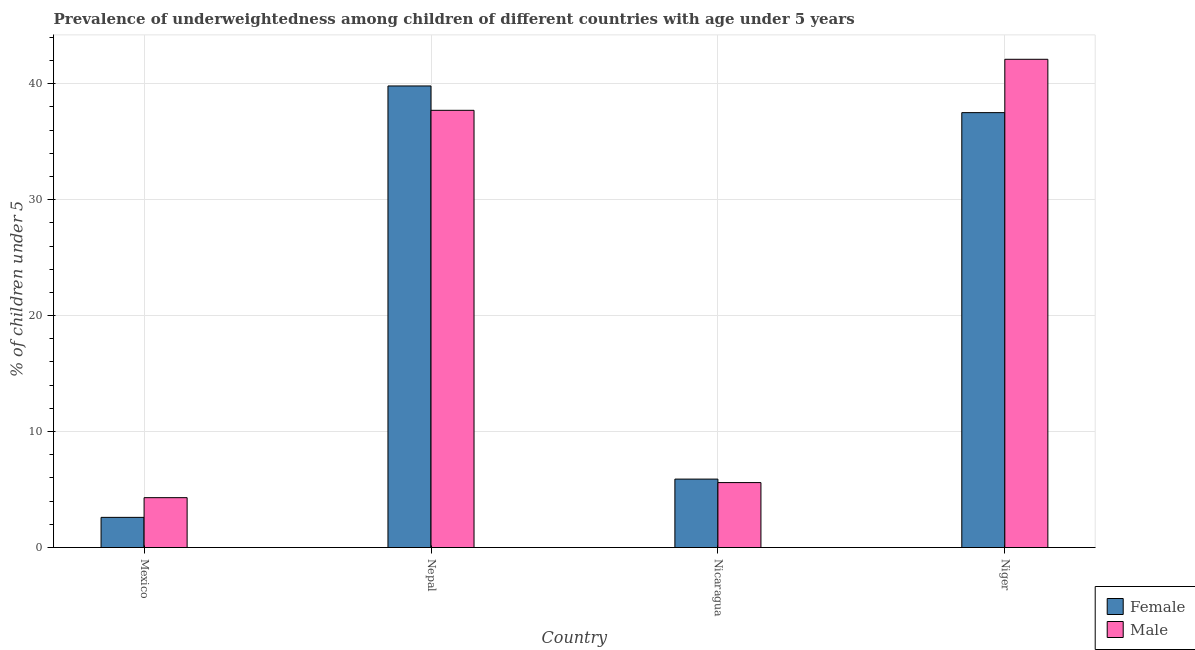How many groups of bars are there?
Offer a very short reply. 4. Are the number of bars per tick equal to the number of legend labels?
Make the answer very short. Yes. What is the label of the 1st group of bars from the left?
Offer a very short reply. Mexico. In how many cases, is the number of bars for a given country not equal to the number of legend labels?
Offer a terse response. 0. What is the percentage of underweighted male children in Nicaragua?
Provide a short and direct response. 5.6. Across all countries, what is the maximum percentage of underweighted female children?
Offer a terse response. 39.8. Across all countries, what is the minimum percentage of underweighted female children?
Provide a short and direct response. 2.6. In which country was the percentage of underweighted male children maximum?
Keep it short and to the point. Niger. What is the total percentage of underweighted male children in the graph?
Offer a terse response. 89.7. What is the difference between the percentage of underweighted male children in Mexico and that in Nepal?
Your answer should be compact. -33.4. What is the difference between the percentage of underweighted male children in Mexico and the percentage of underweighted female children in Nepal?
Make the answer very short. -35.5. What is the average percentage of underweighted female children per country?
Make the answer very short. 21.45. What is the difference between the percentage of underweighted male children and percentage of underweighted female children in Mexico?
Your answer should be compact. 1.7. In how many countries, is the percentage of underweighted male children greater than 14 %?
Offer a terse response. 2. What is the ratio of the percentage of underweighted female children in Nicaragua to that in Niger?
Provide a short and direct response. 0.16. Is the percentage of underweighted male children in Mexico less than that in Nepal?
Provide a short and direct response. Yes. What is the difference between the highest and the second highest percentage of underweighted female children?
Your response must be concise. 2.3. What is the difference between the highest and the lowest percentage of underweighted female children?
Provide a succinct answer. 37.2. Is the sum of the percentage of underweighted female children in Mexico and Nepal greater than the maximum percentage of underweighted male children across all countries?
Your response must be concise. Yes. What does the 1st bar from the left in Niger represents?
Your response must be concise. Female. What does the 2nd bar from the right in Mexico represents?
Offer a terse response. Female. What is the difference between two consecutive major ticks on the Y-axis?
Offer a terse response. 10. Are the values on the major ticks of Y-axis written in scientific E-notation?
Provide a short and direct response. No. How many legend labels are there?
Give a very brief answer. 2. How are the legend labels stacked?
Provide a succinct answer. Vertical. What is the title of the graph?
Ensure brevity in your answer.  Prevalence of underweightedness among children of different countries with age under 5 years. What is the label or title of the Y-axis?
Your answer should be compact.  % of children under 5. What is the  % of children under 5 in Female in Mexico?
Your answer should be very brief. 2.6. What is the  % of children under 5 in Male in Mexico?
Offer a very short reply. 4.3. What is the  % of children under 5 in Female in Nepal?
Your answer should be very brief. 39.8. What is the  % of children under 5 of Male in Nepal?
Provide a short and direct response. 37.7. What is the  % of children under 5 of Female in Nicaragua?
Keep it short and to the point. 5.9. What is the  % of children under 5 in Male in Nicaragua?
Offer a terse response. 5.6. What is the  % of children under 5 of Female in Niger?
Your answer should be compact. 37.5. What is the  % of children under 5 in Male in Niger?
Provide a succinct answer. 42.1. Across all countries, what is the maximum  % of children under 5 of Female?
Ensure brevity in your answer.  39.8. Across all countries, what is the maximum  % of children under 5 in Male?
Your answer should be very brief. 42.1. Across all countries, what is the minimum  % of children under 5 of Female?
Make the answer very short. 2.6. Across all countries, what is the minimum  % of children under 5 in Male?
Offer a very short reply. 4.3. What is the total  % of children under 5 of Female in the graph?
Your answer should be compact. 85.8. What is the total  % of children under 5 of Male in the graph?
Ensure brevity in your answer.  89.7. What is the difference between the  % of children under 5 of Female in Mexico and that in Nepal?
Ensure brevity in your answer.  -37.2. What is the difference between the  % of children under 5 in Male in Mexico and that in Nepal?
Provide a short and direct response. -33.4. What is the difference between the  % of children under 5 in Female in Mexico and that in Nicaragua?
Provide a succinct answer. -3.3. What is the difference between the  % of children under 5 in Male in Mexico and that in Nicaragua?
Ensure brevity in your answer.  -1.3. What is the difference between the  % of children under 5 of Female in Mexico and that in Niger?
Provide a succinct answer. -34.9. What is the difference between the  % of children under 5 of Male in Mexico and that in Niger?
Your response must be concise. -37.8. What is the difference between the  % of children under 5 of Female in Nepal and that in Nicaragua?
Your answer should be compact. 33.9. What is the difference between the  % of children under 5 in Male in Nepal and that in Nicaragua?
Make the answer very short. 32.1. What is the difference between the  % of children under 5 of Male in Nepal and that in Niger?
Provide a short and direct response. -4.4. What is the difference between the  % of children under 5 of Female in Nicaragua and that in Niger?
Provide a short and direct response. -31.6. What is the difference between the  % of children under 5 of Male in Nicaragua and that in Niger?
Offer a terse response. -36.5. What is the difference between the  % of children under 5 of Female in Mexico and the  % of children under 5 of Male in Nepal?
Ensure brevity in your answer.  -35.1. What is the difference between the  % of children under 5 of Female in Mexico and the  % of children under 5 of Male in Nicaragua?
Keep it short and to the point. -3. What is the difference between the  % of children under 5 of Female in Mexico and the  % of children under 5 of Male in Niger?
Provide a succinct answer. -39.5. What is the difference between the  % of children under 5 of Female in Nepal and the  % of children under 5 of Male in Nicaragua?
Your answer should be very brief. 34.2. What is the difference between the  % of children under 5 of Female in Nepal and the  % of children under 5 of Male in Niger?
Keep it short and to the point. -2.3. What is the difference between the  % of children under 5 of Female in Nicaragua and the  % of children under 5 of Male in Niger?
Offer a terse response. -36.2. What is the average  % of children under 5 of Female per country?
Your answer should be compact. 21.45. What is the average  % of children under 5 of Male per country?
Keep it short and to the point. 22.43. What is the difference between the  % of children under 5 of Female and  % of children under 5 of Male in Mexico?
Your answer should be compact. -1.7. What is the ratio of the  % of children under 5 in Female in Mexico to that in Nepal?
Make the answer very short. 0.07. What is the ratio of the  % of children under 5 of Male in Mexico to that in Nepal?
Provide a succinct answer. 0.11. What is the ratio of the  % of children under 5 in Female in Mexico to that in Nicaragua?
Offer a terse response. 0.44. What is the ratio of the  % of children under 5 in Male in Mexico to that in Nicaragua?
Provide a short and direct response. 0.77. What is the ratio of the  % of children under 5 in Female in Mexico to that in Niger?
Provide a short and direct response. 0.07. What is the ratio of the  % of children under 5 in Male in Mexico to that in Niger?
Make the answer very short. 0.1. What is the ratio of the  % of children under 5 in Female in Nepal to that in Nicaragua?
Offer a terse response. 6.75. What is the ratio of the  % of children under 5 of Male in Nepal to that in Nicaragua?
Ensure brevity in your answer.  6.73. What is the ratio of the  % of children under 5 in Female in Nepal to that in Niger?
Offer a very short reply. 1.06. What is the ratio of the  % of children under 5 of Male in Nepal to that in Niger?
Your answer should be compact. 0.9. What is the ratio of the  % of children under 5 in Female in Nicaragua to that in Niger?
Ensure brevity in your answer.  0.16. What is the ratio of the  % of children under 5 of Male in Nicaragua to that in Niger?
Make the answer very short. 0.13. What is the difference between the highest and the second highest  % of children under 5 in Female?
Your response must be concise. 2.3. What is the difference between the highest and the lowest  % of children under 5 in Female?
Give a very brief answer. 37.2. What is the difference between the highest and the lowest  % of children under 5 of Male?
Provide a succinct answer. 37.8. 